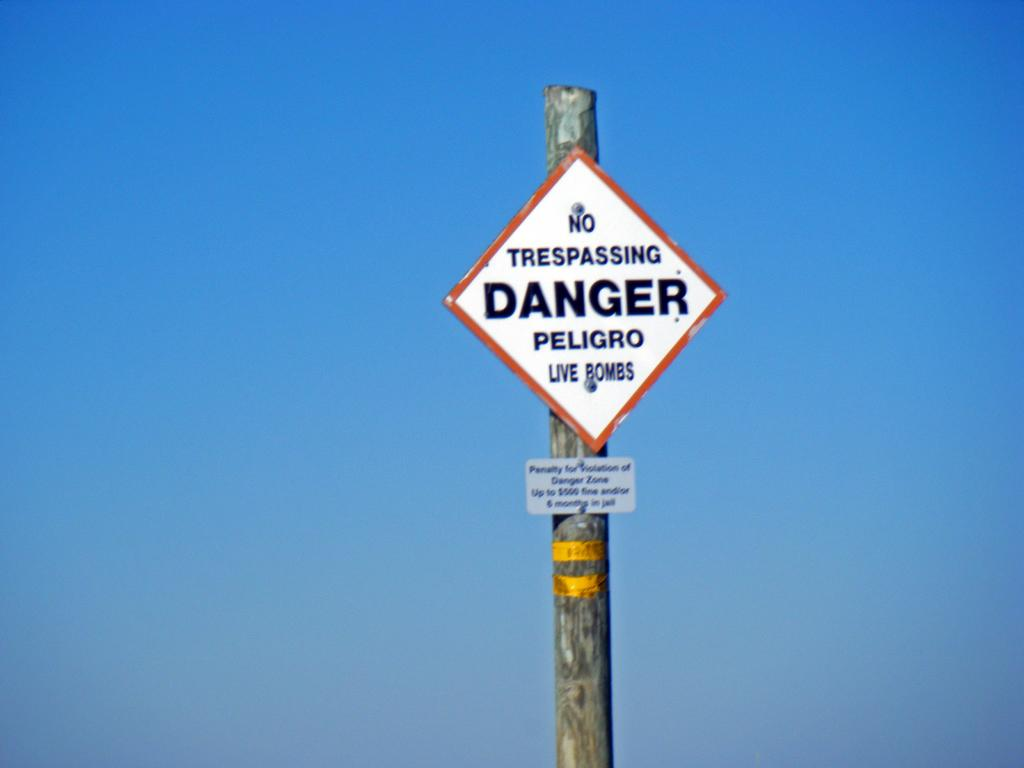<image>
Describe the image concisely. a sign with the word danger on it 